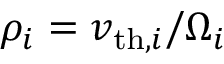<formula> <loc_0><loc_0><loc_500><loc_500>\rho _ { i } = v _ { t h , i } / \Omega _ { i }</formula> 